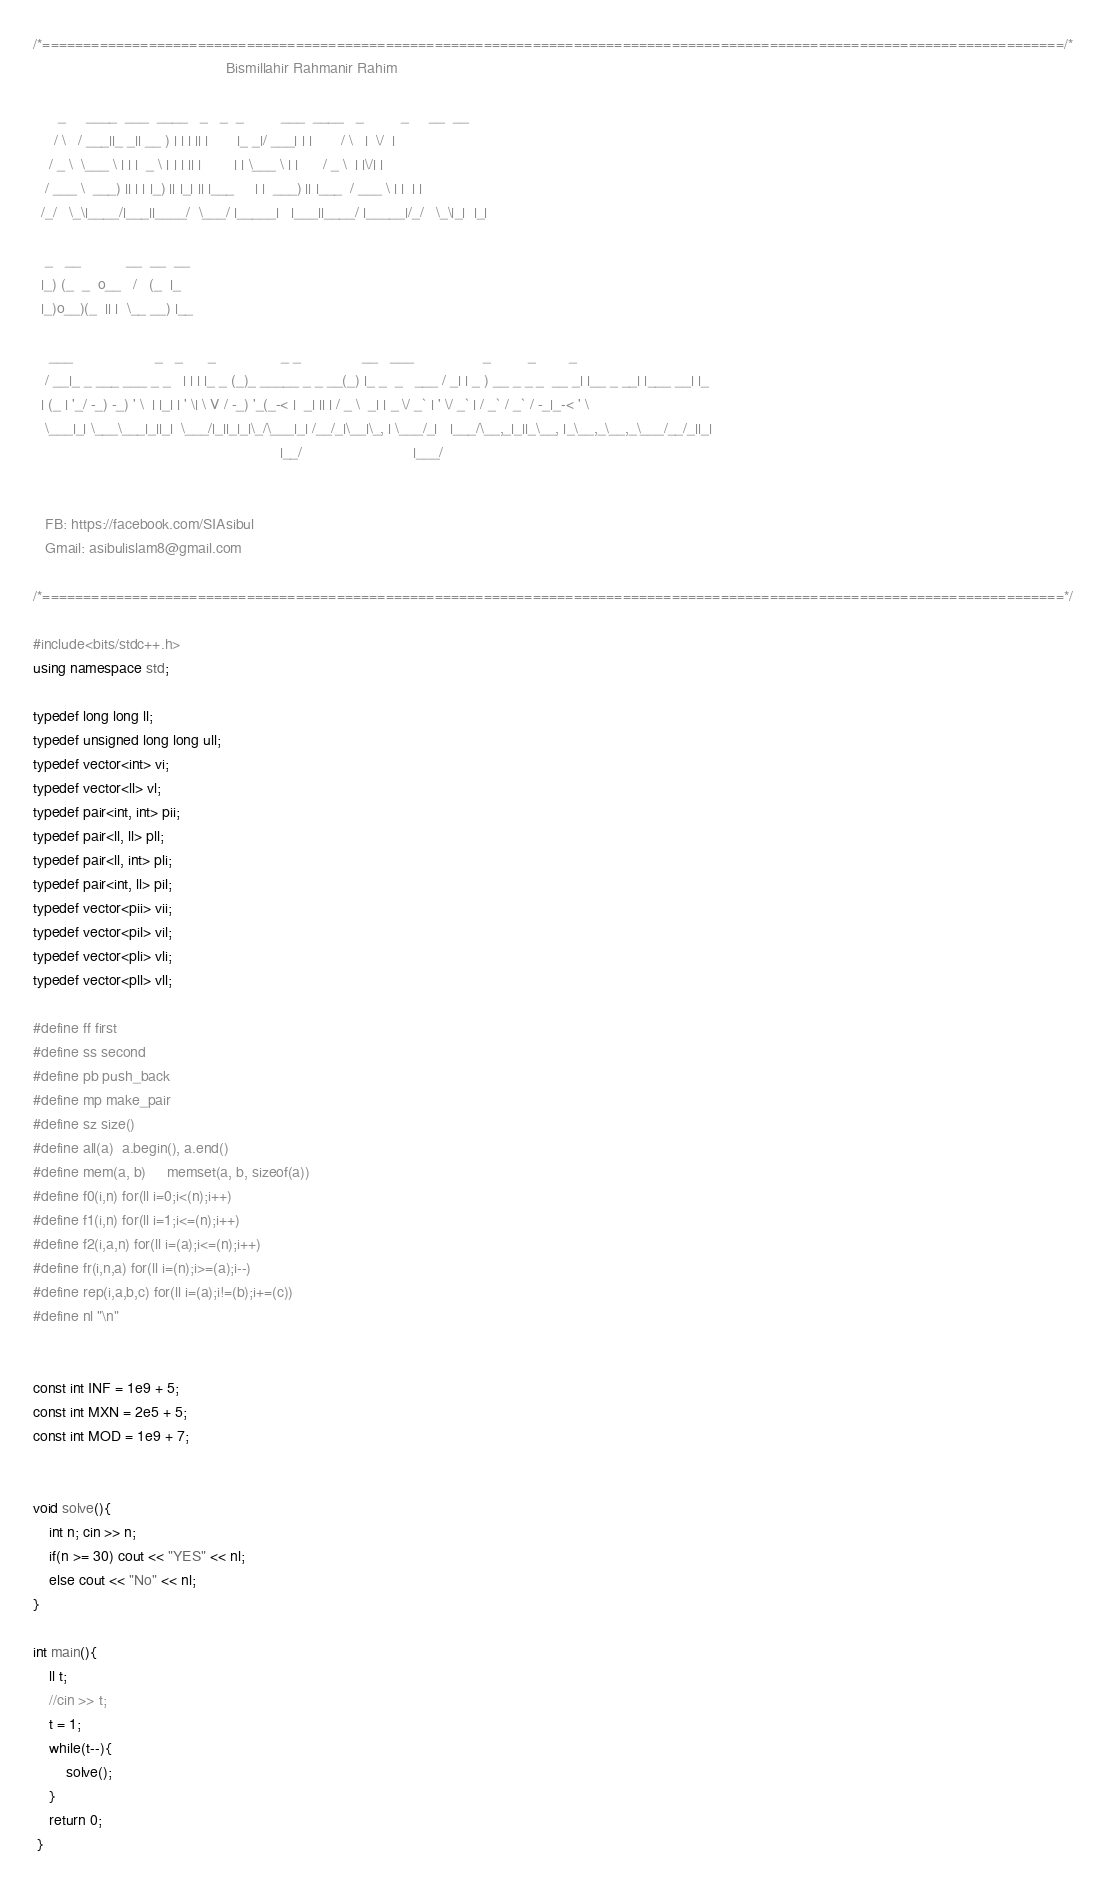<code> <loc_0><loc_0><loc_500><loc_500><_C++_>/*=============================================================================================================================/*
                                               Bismillahir Rahmanir Rahim

      _     ____  ___  ____   _   _  _         ___  ____   _         _     __  __
     / \   / ___||_ _|| __ ) | | | || |       |_ _|/ ___| | |       / \   |  \/  |
    / _ \  \___ \ | | |  _ \ | | | || |        | | \___ \ | |      / _ \  | |\/| |
   / ___ \  ___) || | | |_) || |_| || |___     | |  ___) || |___  / ___ \ | |  | |
  /_/   \_\|____/|___||____/  \___/ |_____|   |___||____/ |_____|/_/   \_\|_|  |_|

   _   __           __  __  __
  |_) (_  _  o__   /   (_  |_
  |_)o__)(_  || |  \__ __) |__

    ___                    _   _      _                _ _               __   ___                 _         _        _
   / __|_ _ ___ ___ _ _   | | | |_ _ (_)_ _____ _ _ __(_) |_ _  _   ___ / _| | _ ) __ _ _ _  __ _| |__ _ __| |___ __| |_
  | (_ | '_/ -_) -_) ' \  | |_| | ' \| \ V / -_) '_(_-< |  _| || | / _ \  _| | _ \/ _` | ' \/ _` | / _` / _` / -_|_-< ' \
   \___|_| \___\___|_||_|  \___/|_||_|_|\_/\___|_| /__/_|\__|\_, | \___/_|   |___/\__,_|_||_\__, |_\__,_\__,_\___/__/_||_|
                                                            |__/                           |___/


   FB: https://facebook.com/SIAsibul
   Gmail: asibulislam8@gmail.com

/*=============================================================================================================================*/

#include<bits/stdc++.h>
using namespace std;

typedef long long ll;
typedef unsigned long long ull;
typedef vector<int> vi;
typedef vector<ll> vl;
typedef pair<int, int> pii;
typedef pair<ll, ll> pll;
typedef pair<ll, int> pli;
typedef pair<int, ll> pil;
typedef vector<pii> vii;
typedef vector<pil> vil;
typedef vector<pli> vli;
typedef vector<pll> vll;

#define ff first
#define ss second
#define pb push_back
#define mp make_pair
#define sz size()
#define all(a)  a.begin(), a.end()
#define mem(a, b)     memset(a, b, sizeof(a))
#define f0(i,n) for(ll i=0;i<(n);i++)
#define f1(i,n) for(ll i=1;i<=(n);i++)
#define f2(i,a,n) for(ll i=(a);i<=(n);i++)
#define fr(i,n,a) for(ll i=(n);i>=(a);i--)
#define rep(i,a,b,c) for(ll i=(a);i!=(b);i+=(c))
#define nl "\n"


const int INF = 1e9 + 5;
const int MXN = 2e5 + 5;
const int MOD = 1e9 + 7;


void solve(){
    int n; cin >> n;
    if(n >= 30) cout << "YES" << nl;
    else cout << "No" << nl;
}

int main(){
    ll t;
    //cin >> t;
    t = 1;
    while(t--){
        solve();
    }
    return 0;
 }
</code> 